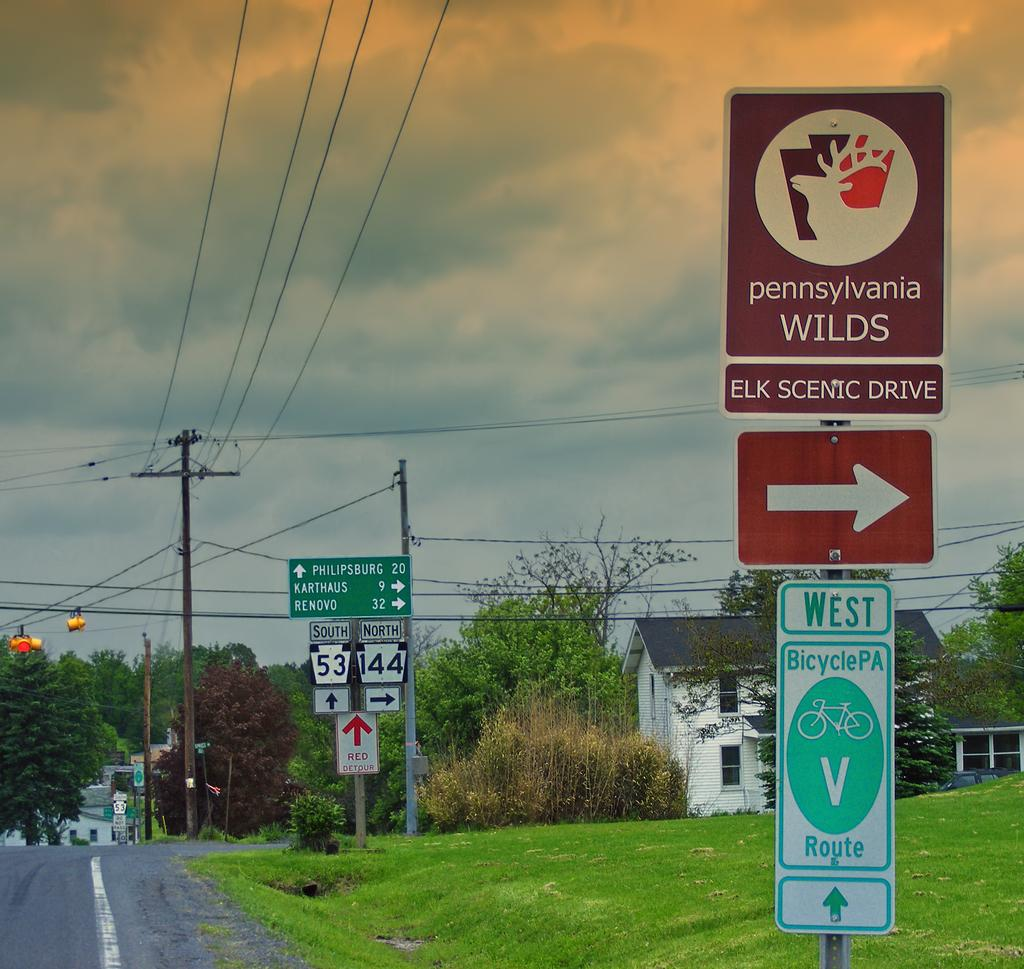<image>
Write a terse but informative summary of the picture. A street has a collection of signs including Elk Scenic drive and a bicycle route. 